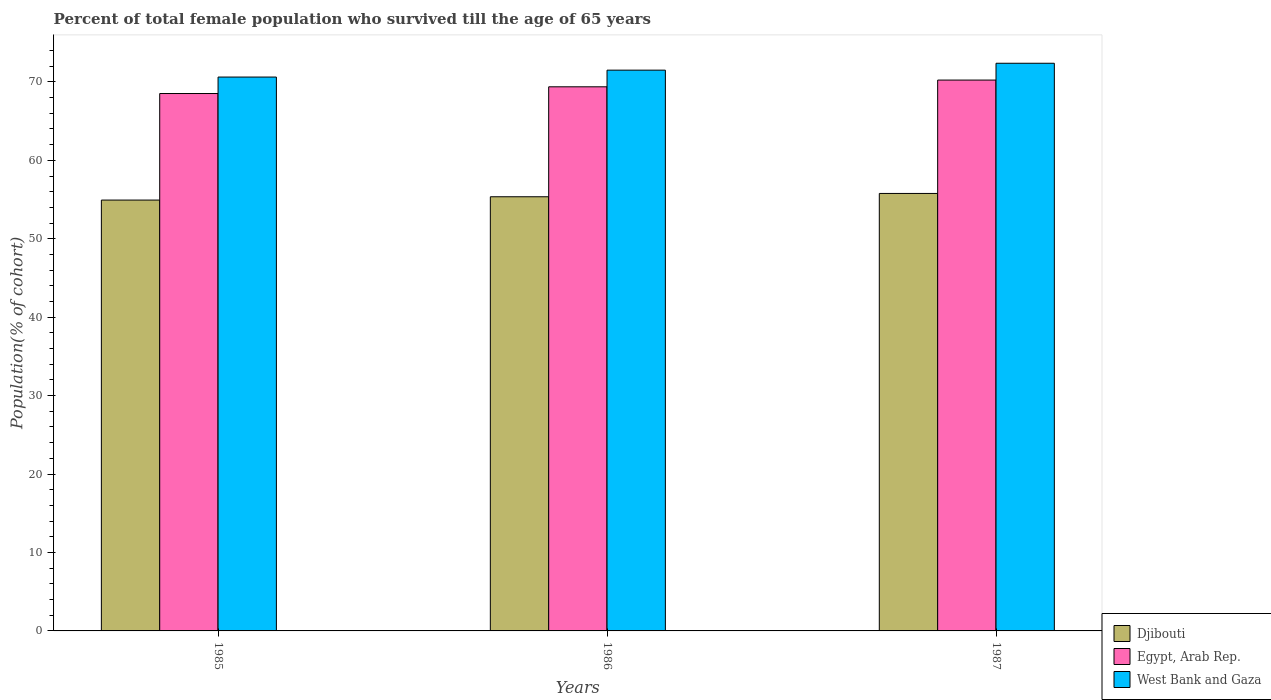Are the number of bars on each tick of the X-axis equal?
Your response must be concise. Yes. How many bars are there on the 3rd tick from the right?
Your answer should be very brief. 3. What is the percentage of total female population who survived till the age of 65 years in Egypt, Arab Rep. in 1985?
Make the answer very short. 68.52. Across all years, what is the maximum percentage of total female population who survived till the age of 65 years in West Bank and Gaza?
Keep it short and to the point. 72.38. Across all years, what is the minimum percentage of total female population who survived till the age of 65 years in Egypt, Arab Rep.?
Ensure brevity in your answer.  68.52. In which year was the percentage of total female population who survived till the age of 65 years in Egypt, Arab Rep. maximum?
Your answer should be very brief. 1987. What is the total percentage of total female population who survived till the age of 65 years in West Bank and Gaza in the graph?
Offer a very short reply. 214.49. What is the difference between the percentage of total female population who survived till the age of 65 years in West Bank and Gaza in 1985 and that in 1987?
Your answer should be compact. -1.76. What is the difference between the percentage of total female population who survived till the age of 65 years in Djibouti in 1986 and the percentage of total female population who survived till the age of 65 years in Egypt, Arab Rep. in 1987?
Offer a very short reply. -14.88. What is the average percentage of total female population who survived till the age of 65 years in Djibouti per year?
Offer a very short reply. 55.35. In the year 1985, what is the difference between the percentage of total female population who survived till the age of 65 years in Egypt, Arab Rep. and percentage of total female population who survived till the age of 65 years in West Bank and Gaza?
Ensure brevity in your answer.  -2.1. What is the ratio of the percentage of total female population who survived till the age of 65 years in Djibouti in 1985 to that in 1986?
Ensure brevity in your answer.  0.99. What is the difference between the highest and the second highest percentage of total female population who survived till the age of 65 years in West Bank and Gaza?
Your answer should be compact. 0.88. What is the difference between the highest and the lowest percentage of total female population who survived till the age of 65 years in West Bank and Gaza?
Give a very brief answer. 1.76. In how many years, is the percentage of total female population who survived till the age of 65 years in West Bank and Gaza greater than the average percentage of total female population who survived till the age of 65 years in West Bank and Gaza taken over all years?
Offer a very short reply. 1. What does the 2nd bar from the left in 1985 represents?
Keep it short and to the point. Egypt, Arab Rep. What does the 2nd bar from the right in 1987 represents?
Offer a very short reply. Egypt, Arab Rep. Is it the case that in every year, the sum of the percentage of total female population who survived till the age of 65 years in West Bank and Gaza and percentage of total female population who survived till the age of 65 years in Djibouti is greater than the percentage of total female population who survived till the age of 65 years in Egypt, Arab Rep.?
Your answer should be compact. Yes. How many bars are there?
Your answer should be very brief. 9. How many years are there in the graph?
Give a very brief answer. 3. Does the graph contain grids?
Provide a short and direct response. No. Where does the legend appear in the graph?
Provide a succinct answer. Bottom right. How are the legend labels stacked?
Give a very brief answer. Vertical. What is the title of the graph?
Offer a terse response. Percent of total female population who survived till the age of 65 years. Does "Venezuela" appear as one of the legend labels in the graph?
Ensure brevity in your answer.  No. What is the label or title of the X-axis?
Your response must be concise. Years. What is the label or title of the Y-axis?
Provide a succinct answer. Population(% of cohort). What is the Population(% of cohort) of Djibouti in 1985?
Offer a very short reply. 54.93. What is the Population(% of cohort) in Egypt, Arab Rep. in 1985?
Offer a very short reply. 68.52. What is the Population(% of cohort) in West Bank and Gaza in 1985?
Offer a terse response. 70.62. What is the Population(% of cohort) in Djibouti in 1986?
Ensure brevity in your answer.  55.35. What is the Population(% of cohort) in Egypt, Arab Rep. in 1986?
Ensure brevity in your answer.  69.37. What is the Population(% of cohort) of West Bank and Gaza in 1986?
Offer a very short reply. 71.5. What is the Population(% of cohort) in Djibouti in 1987?
Your response must be concise. 55.78. What is the Population(% of cohort) in Egypt, Arab Rep. in 1987?
Your answer should be very brief. 70.23. What is the Population(% of cohort) of West Bank and Gaza in 1987?
Keep it short and to the point. 72.38. Across all years, what is the maximum Population(% of cohort) in Djibouti?
Keep it short and to the point. 55.78. Across all years, what is the maximum Population(% of cohort) of Egypt, Arab Rep.?
Offer a terse response. 70.23. Across all years, what is the maximum Population(% of cohort) in West Bank and Gaza?
Ensure brevity in your answer.  72.38. Across all years, what is the minimum Population(% of cohort) in Djibouti?
Provide a short and direct response. 54.93. Across all years, what is the minimum Population(% of cohort) of Egypt, Arab Rep.?
Give a very brief answer. 68.52. Across all years, what is the minimum Population(% of cohort) in West Bank and Gaza?
Give a very brief answer. 70.62. What is the total Population(% of cohort) in Djibouti in the graph?
Give a very brief answer. 166.06. What is the total Population(% of cohort) of Egypt, Arab Rep. in the graph?
Make the answer very short. 208.12. What is the total Population(% of cohort) of West Bank and Gaza in the graph?
Give a very brief answer. 214.49. What is the difference between the Population(% of cohort) in Djibouti in 1985 and that in 1986?
Offer a very short reply. -0.42. What is the difference between the Population(% of cohort) of Egypt, Arab Rep. in 1985 and that in 1986?
Your response must be concise. -0.86. What is the difference between the Population(% of cohort) in West Bank and Gaza in 1985 and that in 1986?
Your answer should be very brief. -0.88. What is the difference between the Population(% of cohort) in Djibouti in 1985 and that in 1987?
Provide a succinct answer. -0.84. What is the difference between the Population(% of cohort) in Egypt, Arab Rep. in 1985 and that in 1987?
Your answer should be compact. -1.72. What is the difference between the Population(% of cohort) in West Bank and Gaza in 1985 and that in 1987?
Your response must be concise. -1.76. What is the difference between the Population(% of cohort) in Djibouti in 1986 and that in 1987?
Make the answer very short. -0.42. What is the difference between the Population(% of cohort) of Egypt, Arab Rep. in 1986 and that in 1987?
Offer a very short reply. -0.86. What is the difference between the Population(% of cohort) of West Bank and Gaza in 1986 and that in 1987?
Your response must be concise. -0.88. What is the difference between the Population(% of cohort) of Djibouti in 1985 and the Population(% of cohort) of Egypt, Arab Rep. in 1986?
Your answer should be compact. -14.44. What is the difference between the Population(% of cohort) of Djibouti in 1985 and the Population(% of cohort) of West Bank and Gaza in 1986?
Your response must be concise. -16.56. What is the difference between the Population(% of cohort) in Egypt, Arab Rep. in 1985 and the Population(% of cohort) in West Bank and Gaza in 1986?
Make the answer very short. -2.98. What is the difference between the Population(% of cohort) of Djibouti in 1985 and the Population(% of cohort) of Egypt, Arab Rep. in 1987?
Make the answer very short. -15.3. What is the difference between the Population(% of cohort) in Djibouti in 1985 and the Population(% of cohort) in West Bank and Gaza in 1987?
Provide a succinct answer. -17.44. What is the difference between the Population(% of cohort) in Egypt, Arab Rep. in 1985 and the Population(% of cohort) in West Bank and Gaza in 1987?
Provide a succinct answer. -3.86. What is the difference between the Population(% of cohort) in Djibouti in 1986 and the Population(% of cohort) in Egypt, Arab Rep. in 1987?
Your answer should be compact. -14.88. What is the difference between the Population(% of cohort) of Djibouti in 1986 and the Population(% of cohort) of West Bank and Gaza in 1987?
Give a very brief answer. -17.02. What is the difference between the Population(% of cohort) of Egypt, Arab Rep. in 1986 and the Population(% of cohort) of West Bank and Gaza in 1987?
Ensure brevity in your answer.  -3. What is the average Population(% of cohort) of Djibouti per year?
Offer a terse response. 55.35. What is the average Population(% of cohort) in Egypt, Arab Rep. per year?
Your answer should be compact. 69.37. What is the average Population(% of cohort) of West Bank and Gaza per year?
Ensure brevity in your answer.  71.5. In the year 1985, what is the difference between the Population(% of cohort) of Djibouti and Population(% of cohort) of Egypt, Arab Rep.?
Provide a succinct answer. -13.58. In the year 1985, what is the difference between the Population(% of cohort) of Djibouti and Population(% of cohort) of West Bank and Gaza?
Your response must be concise. -15.68. In the year 1985, what is the difference between the Population(% of cohort) of Egypt, Arab Rep. and Population(% of cohort) of West Bank and Gaza?
Provide a short and direct response. -2.1. In the year 1986, what is the difference between the Population(% of cohort) of Djibouti and Population(% of cohort) of Egypt, Arab Rep.?
Give a very brief answer. -14.02. In the year 1986, what is the difference between the Population(% of cohort) in Djibouti and Population(% of cohort) in West Bank and Gaza?
Provide a short and direct response. -16.14. In the year 1986, what is the difference between the Population(% of cohort) of Egypt, Arab Rep. and Population(% of cohort) of West Bank and Gaza?
Your answer should be compact. -2.12. In the year 1987, what is the difference between the Population(% of cohort) in Djibouti and Population(% of cohort) in Egypt, Arab Rep.?
Your answer should be compact. -14.46. In the year 1987, what is the difference between the Population(% of cohort) in Djibouti and Population(% of cohort) in West Bank and Gaza?
Offer a terse response. -16.6. In the year 1987, what is the difference between the Population(% of cohort) in Egypt, Arab Rep. and Population(% of cohort) in West Bank and Gaza?
Give a very brief answer. -2.14. What is the ratio of the Population(% of cohort) of Egypt, Arab Rep. in 1985 to that in 1986?
Provide a short and direct response. 0.99. What is the ratio of the Population(% of cohort) in West Bank and Gaza in 1985 to that in 1986?
Your response must be concise. 0.99. What is the ratio of the Population(% of cohort) of Djibouti in 1985 to that in 1987?
Keep it short and to the point. 0.98. What is the ratio of the Population(% of cohort) in Egypt, Arab Rep. in 1985 to that in 1987?
Give a very brief answer. 0.98. What is the ratio of the Population(% of cohort) in West Bank and Gaza in 1985 to that in 1987?
Ensure brevity in your answer.  0.98. What is the ratio of the Population(% of cohort) of Egypt, Arab Rep. in 1986 to that in 1987?
Give a very brief answer. 0.99. What is the ratio of the Population(% of cohort) of West Bank and Gaza in 1986 to that in 1987?
Give a very brief answer. 0.99. What is the difference between the highest and the second highest Population(% of cohort) in Djibouti?
Provide a short and direct response. 0.42. What is the difference between the highest and the second highest Population(% of cohort) of Egypt, Arab Rep.?
Make the answer very short. 0.86. What is the difference between the highest and the second highest Population(% of cohort) in West Bank and Gaza?
Provide a succinct answer. 0.88. What is the difference between the highest and the lowest Population(% of cohort) in Djibouti?
Offer a very short reply. 0.84. What is the difference between the highest and the lowest Population(% of cohort) of Egypt, Arab Rep.?
Keep it short and to the point. 1.72. What is the difference between the highest and the lowest Population(% of cohort) in West Bank and Gaza?
Ensure brevity in your answer.  1.76. 